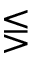Convert formula to latex. <formula><loc_0><loc_0><loc_500><loc_500>\leq s s e q g t r</formula> 